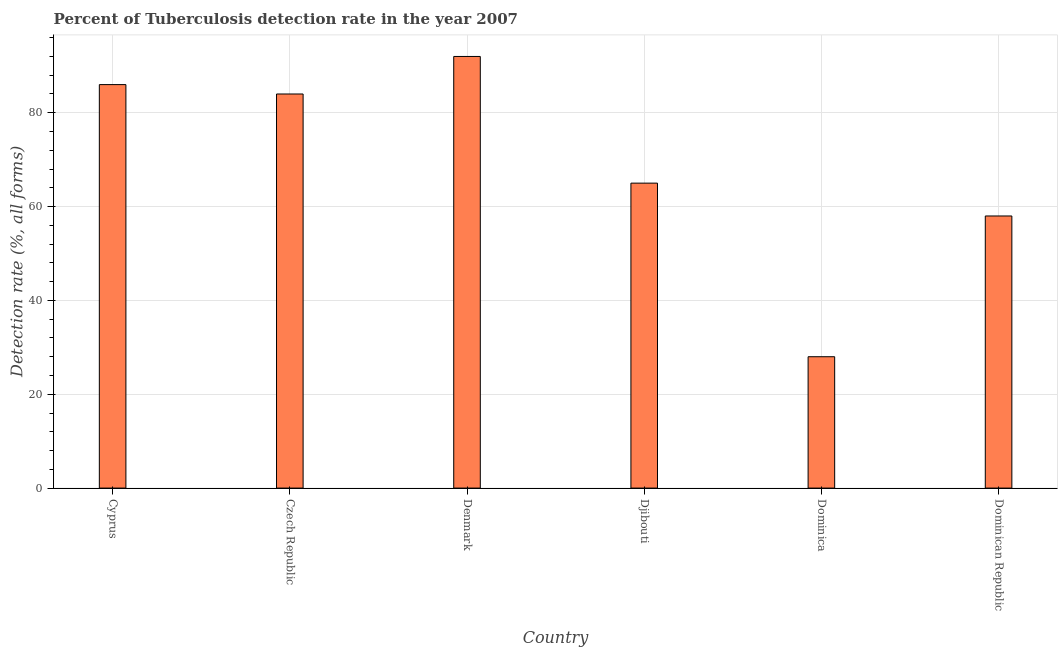Does the graph contain any zero values?
Your answer should be compact. No. What is the title of the graph?
Your answer should be compact. Percent of Tuberculosis detection rate in the year 2007. What is the label or title of the X-axis?
Your answer should be very brief. Country. What is the label or title of the Y-axis?
Offer a terse response. Detection rate (%, all forms). What is the detection rate of tuberculosis in Djibouti?
Your answer should be very brief. 65. Across all countries, what is the maximum detection rate of tuberculosis?
Offer a terse response. 92. Across all countries, what is the minimum detection rate of tuberculosis?
Give a very brief answer. 28. In which country was the detection rate of tuberculosis minimum?
Your response must be concise. Dominica. What is the sum of the detection rate of tuberculosis?
Ensure brevity in your answer.  413. What is the average detection rate of tuberculosis per country?
Provide a succinct answer. 68. What is the median detection rate of tuberculosis?
Offer a terse response. 74.5. What is the ratio of the detection rate of tuberculosis in Cyprus to that in Denmark?
Your answer should be compact. 0.94. Is the detection rate of tuberculosis in Czech Republic less than that in Dominican Republic?
Offer a terse response. No. Is the difference between the detection rate of tuberculosis in Czech Republic and Djibouti greater than the difference between any two countries?
Provide a succinct answer. No. Is the sum of the detection rate of tuberculosis in Cyprus and Djibouti greater than the maximum detection rate of tuberculosis across all countries?
Give a very brief answer. Yes. What is the difference between the highest and the lowest detection rate of tuberculosis?
Make the answer very short. 64. In how many countries, is the detection rate of tuberculosis greater than the average detection rate of tuberculosis taken over all countries?
Your answer should be compact. 3. Are all the bars in the graph horizontal?
Offer a very short reply. No. How many countries are there in the graph?
Offer a terse response. 6. What is the difference between two consecutive major ticks on the Y-axis?
Offer a terse response. 20. Are the values on the major ticks of Y-axis written in scientific E-notation?
Provide a short and direct response. No. What is the Detection rate (%, all forms) in Czech Republic?
Give a very brief answer. 84. What is the Detection rate (%, all forms) in Denmark?
Make the answer very short. 92. What is the Detection rate (%, all forms) of Djibouti?
Offer a terse response. 65. What is the Detection rate (%, all forms) of Dominican Republic?
Your response must be concise. 58. What is the difference between the Detection rate (%, all forms) in Cyprus and Denmark?
Offer a terse response. -6. What is the difference between the Detection rate (%, all forms) in Cyprus and Djibouti?
Ensure brevity in your answer.  21. What is the difference between the Detection rate (%, all forms) in Cyprus and Dominica?
Give a very brief answer. 58. What is the difference between the Detection rate (%, all forms) in Czech Republic and Denmark?
Offer a terse response. -8. What is the difference between the Detection rate (%, all forms) in Czech Republic and Dominica?
Keep it short and to the point. 56. What is the difference between the Detection rate (%, all forms) in Denmark and Djibouti?
Your response must be concise. 27. What is the difference between the Detection rate (%, all forms) in Denmark and Dominican Republic?
Ensure brevity in your answer.  34. What is the difference between the Detection rate (%, all forms) in Djibouti and Dominican Republic?
Your answer should be very brief. 7. What is the difference between the Detection rate (%, all forms) in Dominica and Dominican Republic?
Offer a terse response. -30. What is the ratio of the Detection rate (%, all forms) in Cyprus to that in Denmark?
Offer a terse response. 0.94. What is the ratio of the Detection rate (%, all forms) in Cyprus to that in Djibouti?
Offer a terse response. 1.32. What is the ratio of the Detection rate (%, all forms) in Cyprus to that in Dominica?
Make the answer very short. 3.07. What is the ratio of the Detection rate (%, all forms) in Cyprus to that in Dominican Republic?
Offer a very short reply. 1.48. What is the ratio of the Detection rate (%, all forms) in Czech Republic to that in Denmark?
Ensure brevity in your answer.  0.91. What is the ratio of the Detection rate (%, all forms) in Czech Republic to that in Djibouti?
Your answer should be compact. 1.29. What is the ratio of the Detection rate (%, all forms) in Czech Republic to that in Dominican Republic?
Offer a very short reply. 1.45. What is the ratio of the Detection rate (%, all forms) in Denmark to that in Djibouti?
Provide a short and direct response. 1.42. What is the ratio of the Detection rate (%, all forms) in Denmark to that in Dominica?
Provide a short and direct response. 3.29. What is the ratio of the Detection rate (%, all forms) in Denmark to that in Dominican Republic?
Your answer should be compact. 1.59. What is the ratio of the Detection rate (%, all forms) in Djibouti to that in Dominica?
Your answer should be compact. 2.32. What is the ratio of the Detection rate (%, all forms) in Djibouti to that in Dominican Republic?
Offer a terse response. 1.12. What is the ratio of the Detection rate (%, all forms) in Dominica to that in Dominican Republic?
Provide a succinct answer. 0.48. 